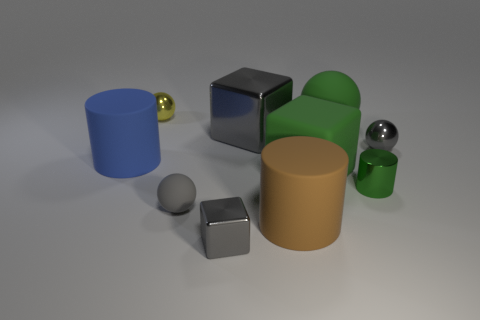Subtract 1 cubes. How many cubes are left? 2 Subtract all cyan balls. Subtract all gray cylinders. How many balls are left? 4 Subtract all blocks. How many objects are left? 7 Subtract 0 yellow cylinders. How many objects are left? 10 Subtract all brown matte blocks. Subtract all small balls. How many objects are left? 7 Add 2 small green shiny things. How many small green shiny things are left? 3 Add 2 large brown rubber objects. How many large brown rubber objects exist? 3 